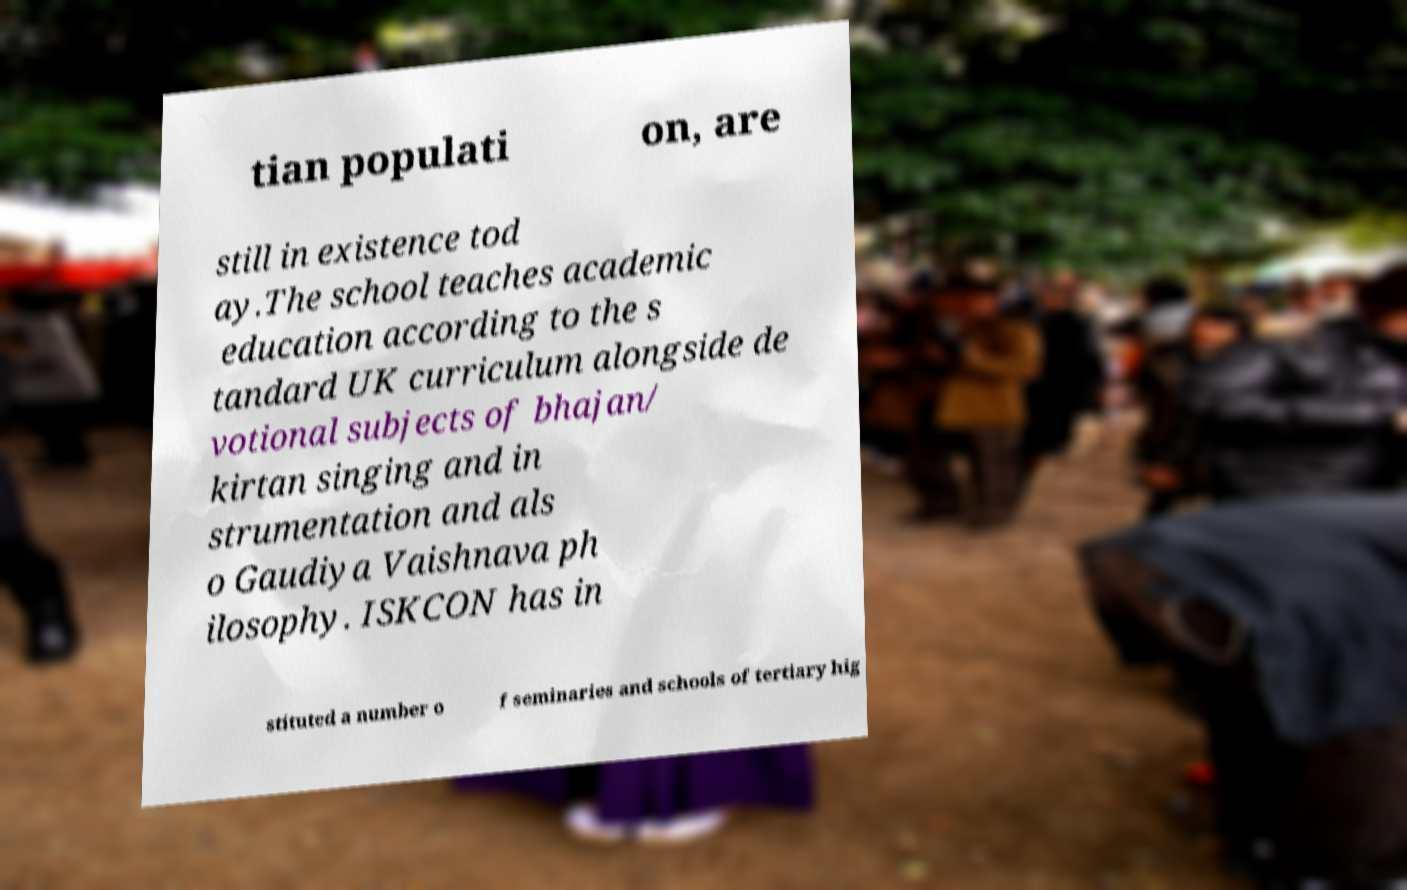Can you read and provide the text displayed in the image?This photo seems to have some interesting text. Can you extract and type it out for me? tian populati on, are still in existence tod ay.The school teaches academic education according to the s tandard UK curriculum alongside de votional subjects of bhajan/ kirtan singing and in strumentation and als o Gaudiya Vaishnava ph ilosophy. ISKCON has in stituted a number o f seminaries and schools of tertiary hig 